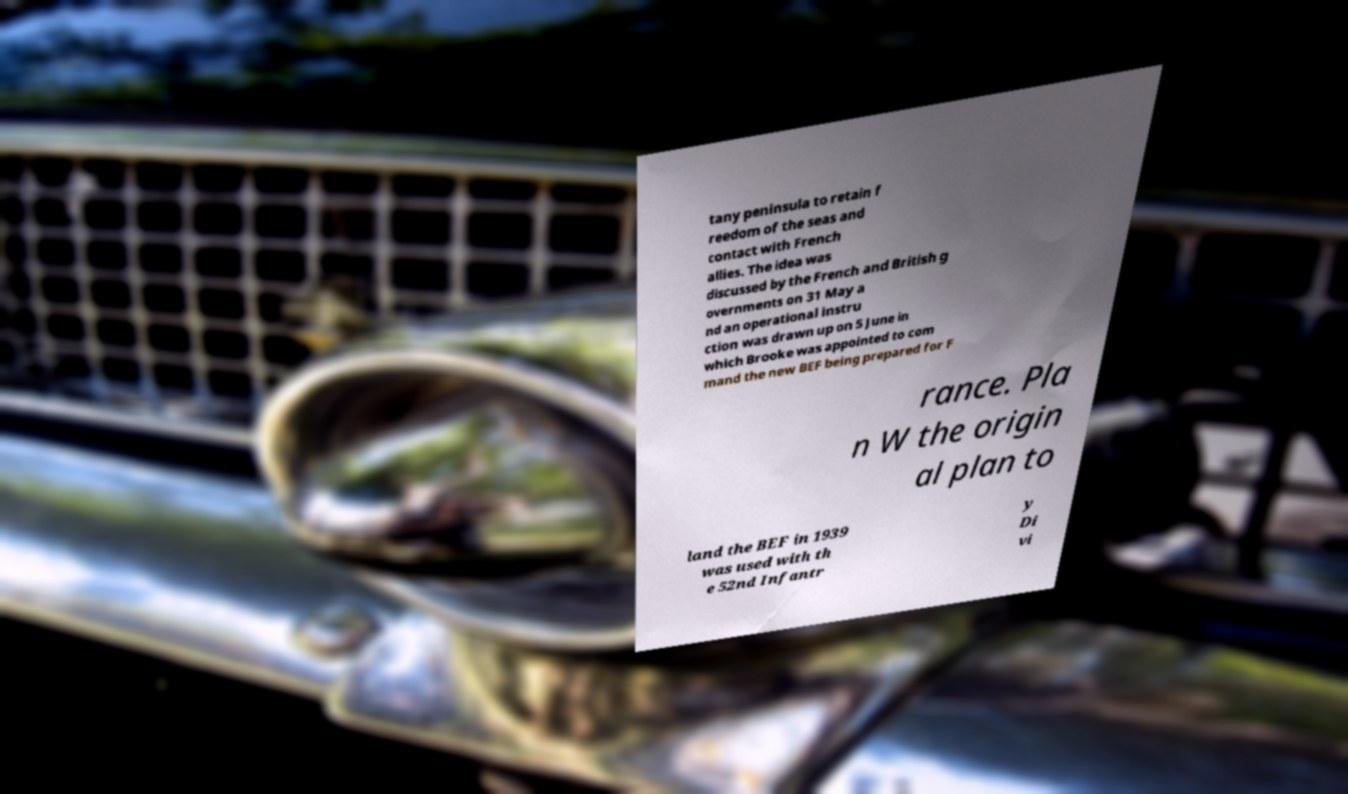Can you accurately transcribe the text from the provided image for me? tany peninsula to retain f reedom of the seas and contact with French allies. The idea was discussed by the French and British g overnments on 31 May a nd an operational instru ction was drawn up on 5 June in which Brooke was appointed to com mand the new BEF being prepared for F rance. Pla n W the origin al plan to land the BEF in 1939 was used with th e 52nd Infantr y Di vi 